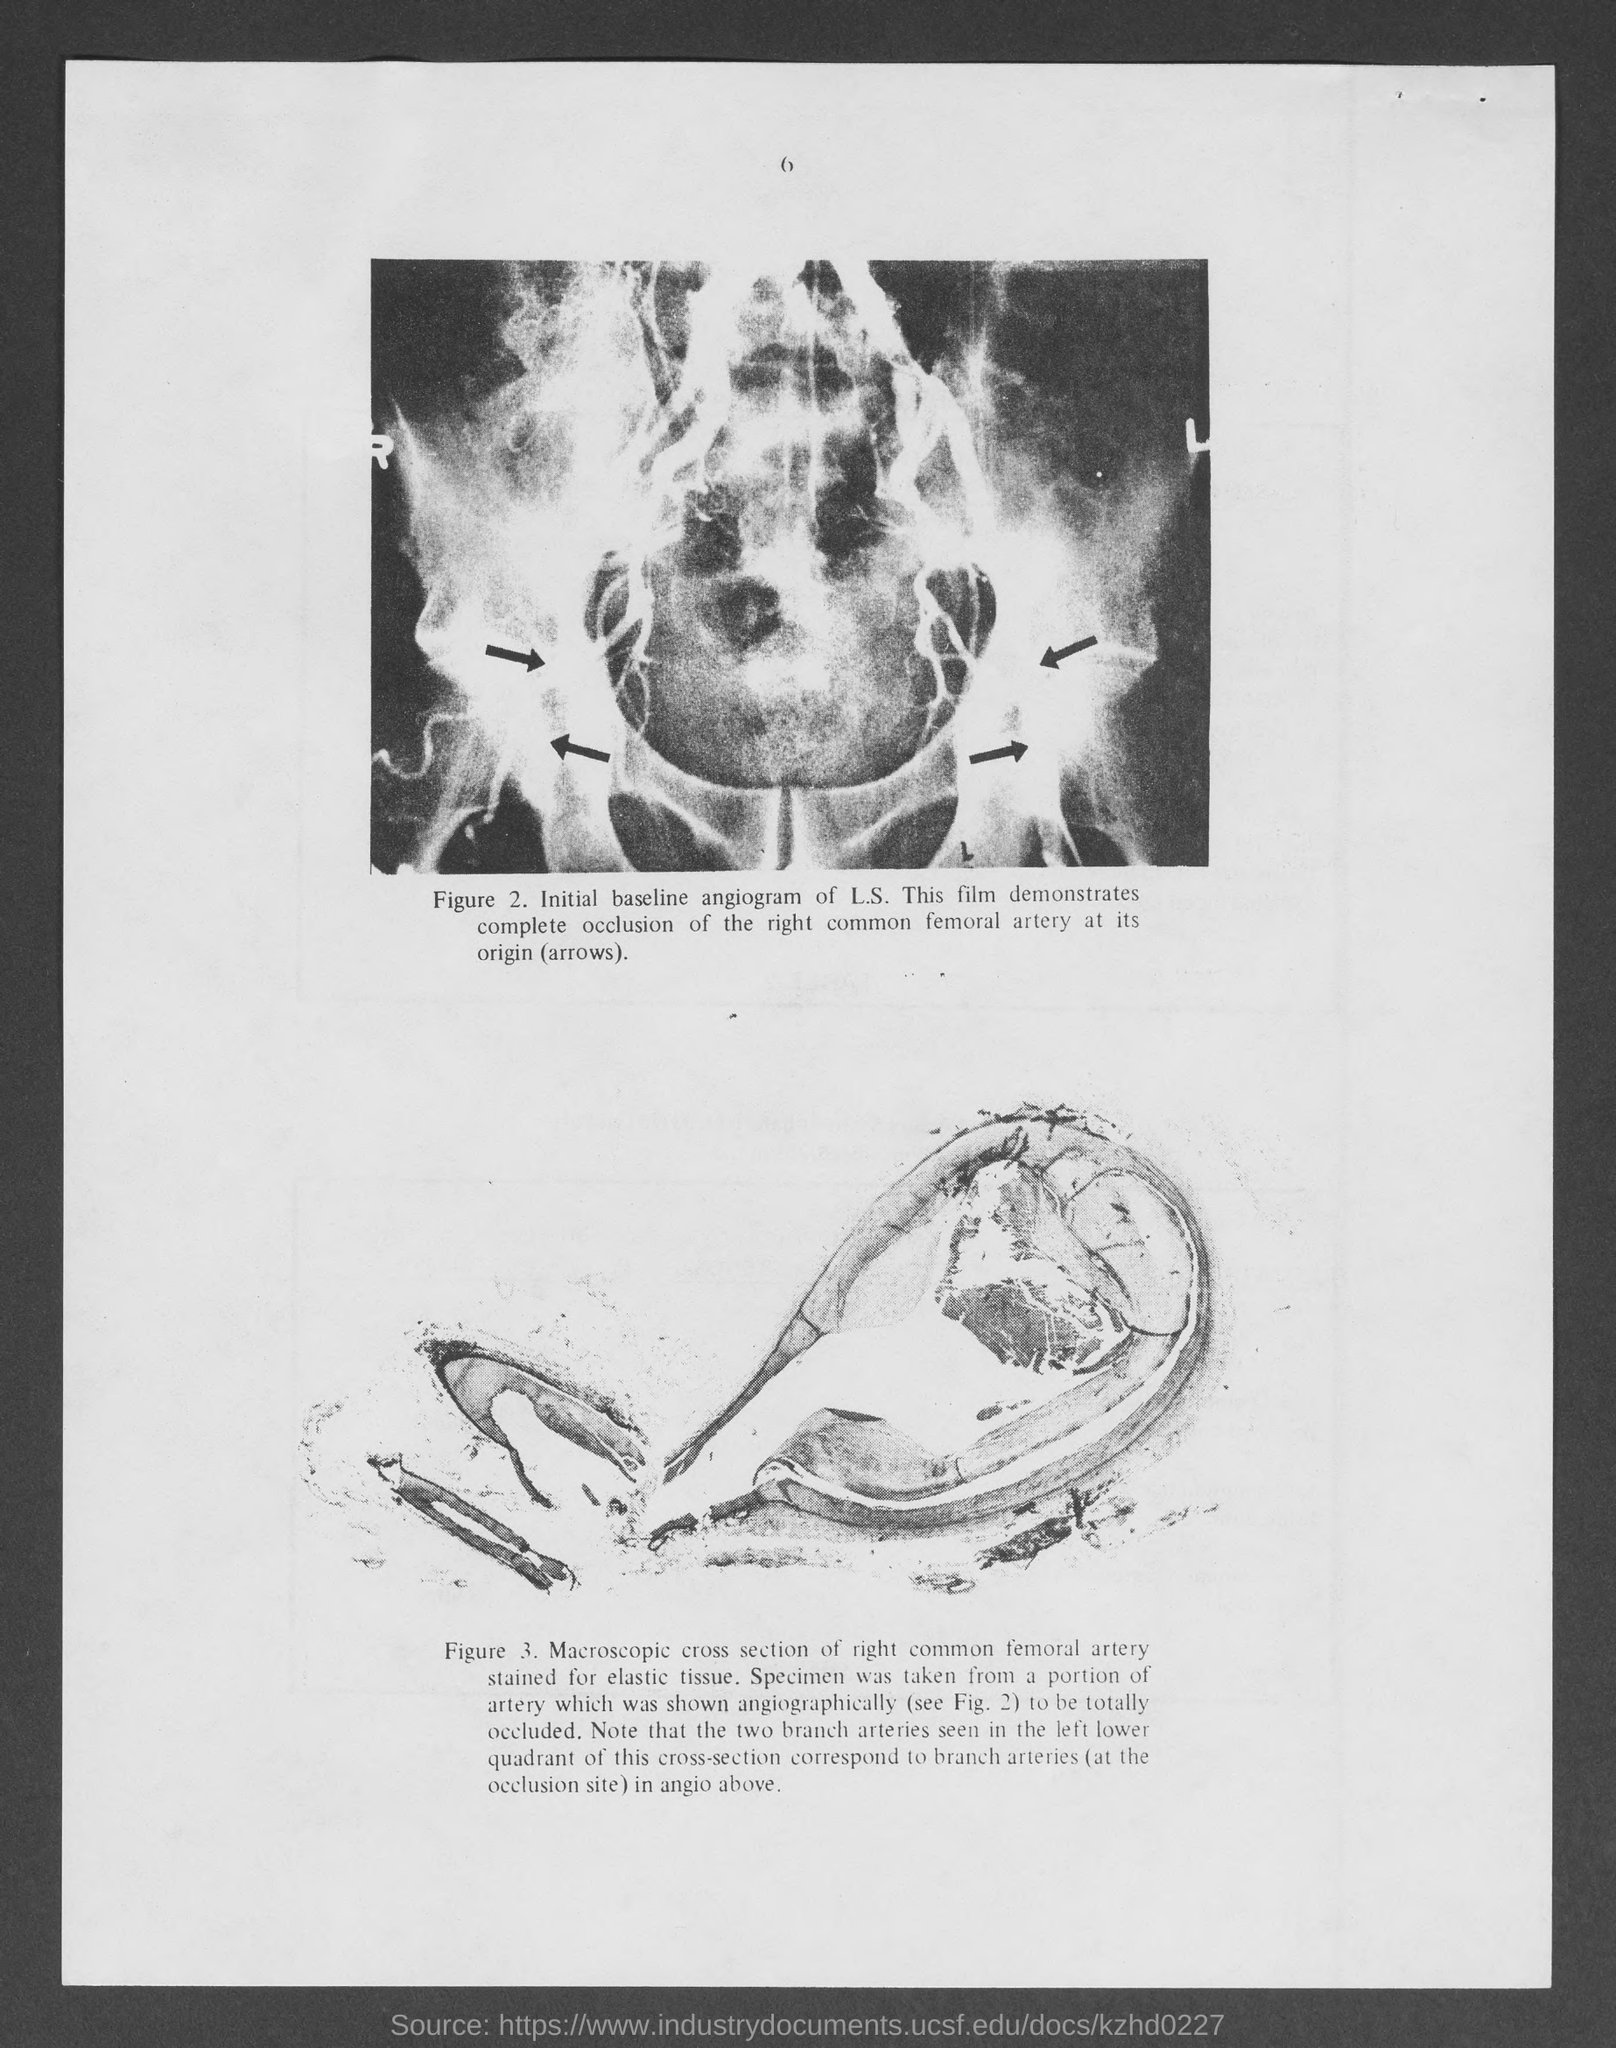What is the number at top of the page ?
Offer a terse response. 6. 